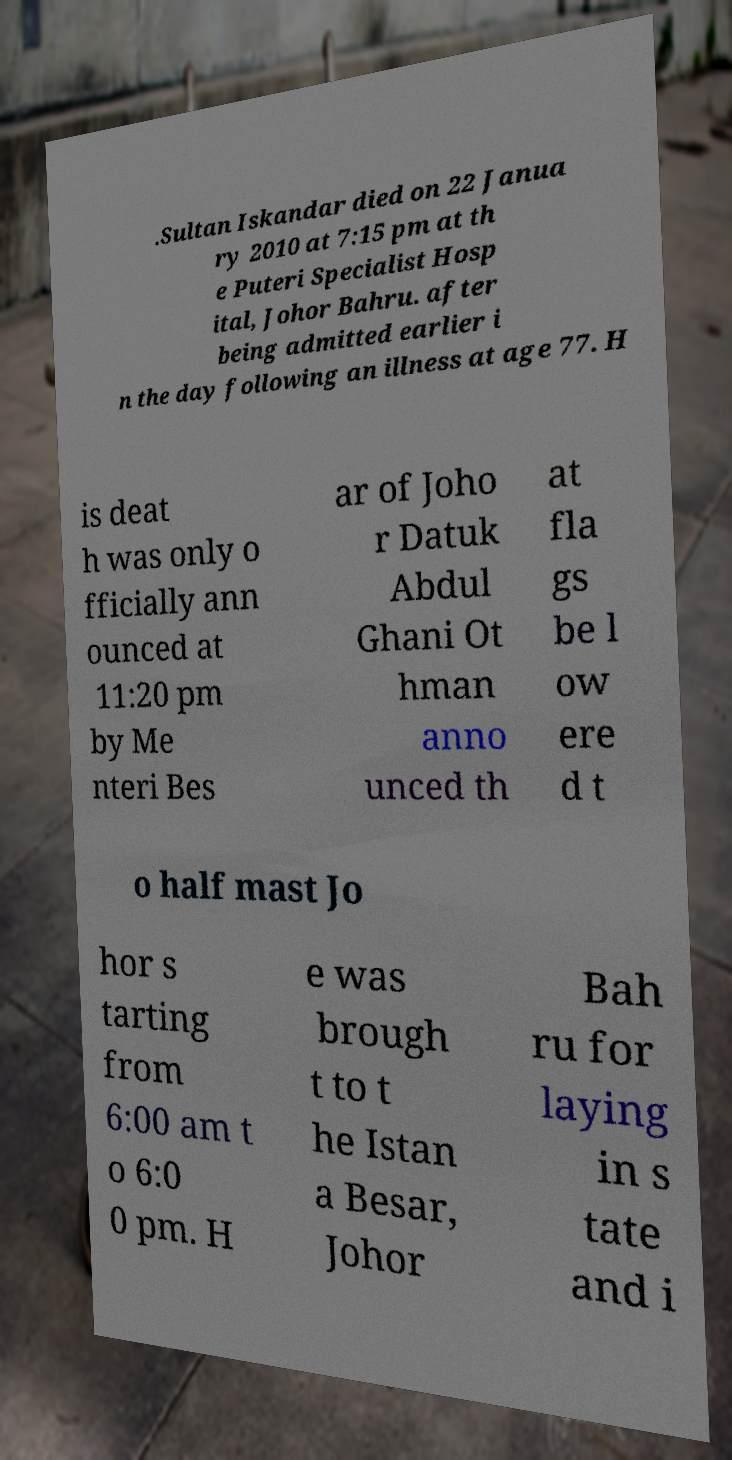Could you assist in decoding the text presented in this image and type it out clearly? .Sultan Iskandar died on 22 Janua ry 2010 at 7:15 pm at th e Puteri Specialist Hosp ital, Johor Bahru. after being admitted earlier i n the day following an illness at age 77. H is deat h was only o fficially ann ounced at 11:20 pm by Me nteri Bes ar of Joho r Datuk Abdul Ghani Ot hman anno unced th at fla gs be l ow ere d t o half mast Jo hor s tarting from 6:00 am t o 6:0 0 pm. H e was brough t to t he Istan a Besar, Johor Bah ru for laying in s tate and i 